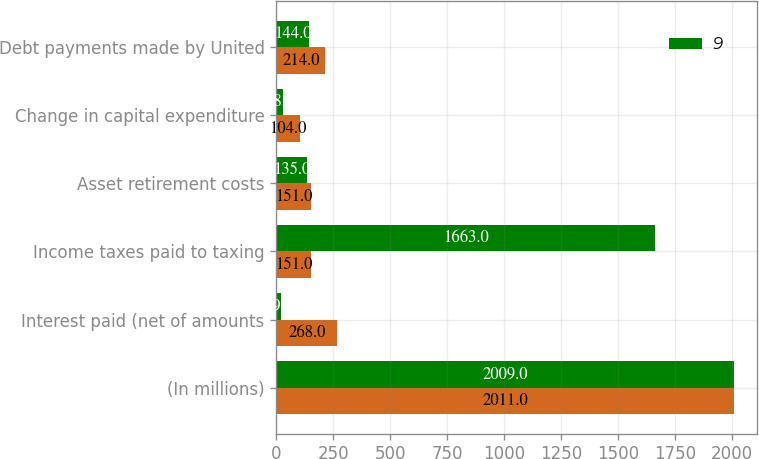Convert chart. <chart><loc_0><loc_0><loc_500><loc_500><stacked_bar_chart><ecel><fcel>(In millions)<fcel>Interest paid (net of amounts<fcel>Income taxes paid to taxing<fcel>Asset retirement costs<fcel>Change in capital expenditure<fcel>Debt payments made by United<nl><fcel>nan<fcel>2011<fcel>268<fcel>151<fcel>151<fcel>104<fcel>214<nl><fcel>9<fcel>2009<fcel>19<fcel>1663<fcel>135<fcel>28<fcel>144<nl></chart> 